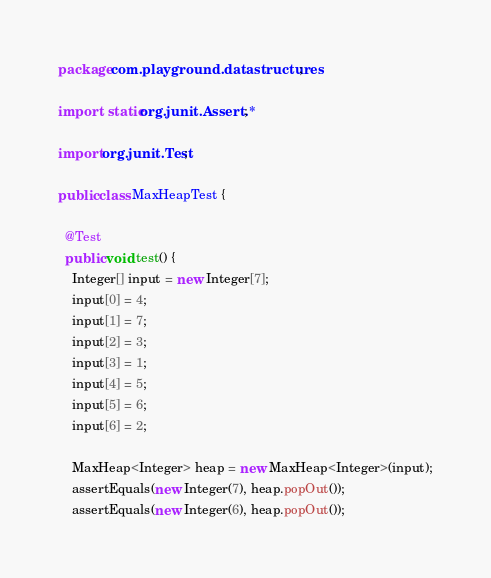<code> <loc_0><loc_0><loc_500><loc_500><_Java_>package com.playground.datastructures;

import static org.junit.Assert.*;

import org.junit.Test;

public class MaxHeapTest {

  @Test
  public void test() {
    Integer[] input = new Integer[7];
    input[0] = 4;
    input[1] = 7;
    input[2] = 3;
    input[3] = 1;
    input[4] = 5;
    input[5] = 6;
    input[6] = 2;

    MaxHeap<Integer> heap = new MaxHeap<Integer>(input);
    assertEquals(new Integer(7), heap.popOut());
    assertEquals(new Integer(6), heap.popOut());</code> 